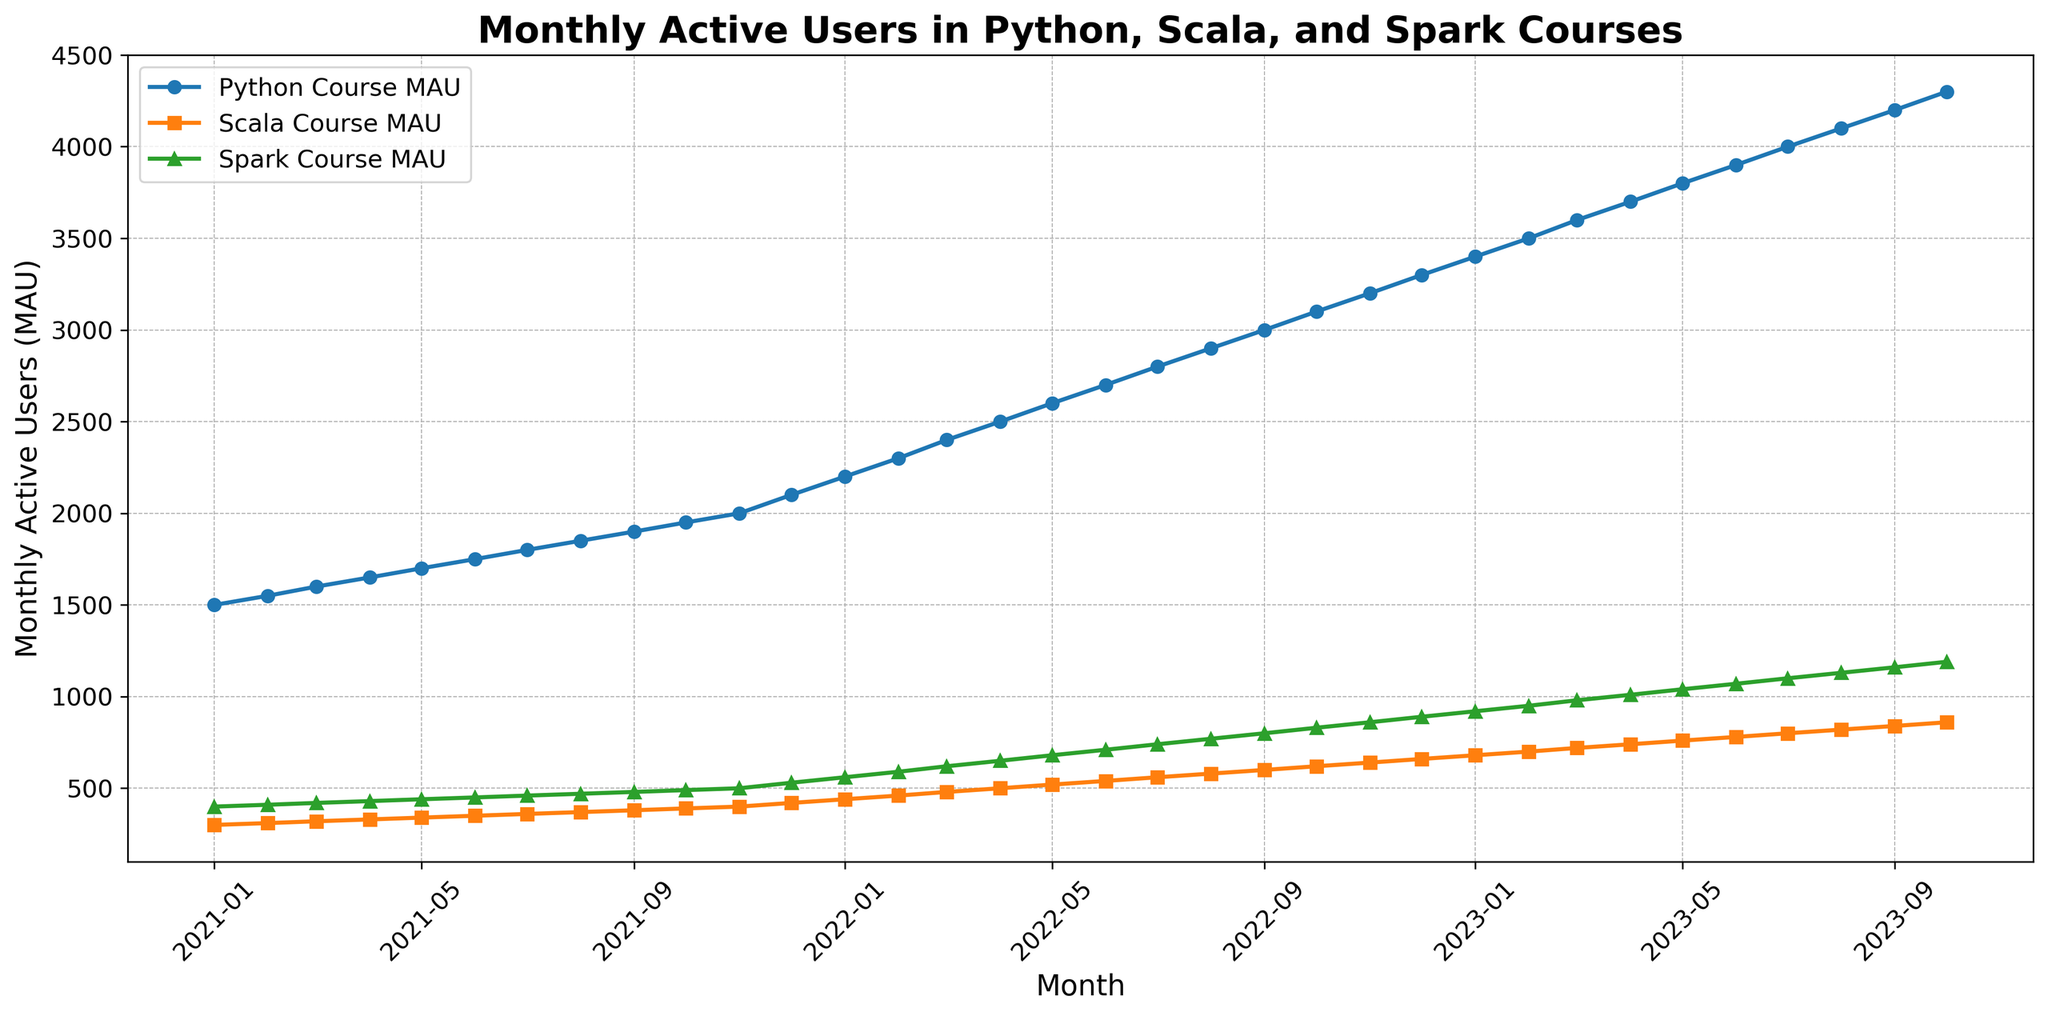What's the average number of Monthly Active Users for the Python course in 2022? Sum the monthly values for Python Course MAU from January 2022 to December 2022 and divide by 12. (2200 + 2300 + 2400 + 2500 + 2600 + 2700 + 2800 + 2900 + 3000 + 3100 + 3200 + 3300) = 35200, and 35200 / 12 = 2933.33. Thus, the average number of Monthly Active Users for the Python course in 2022 is 2933.33
Answer: 2933.33 Which course had the highest Monthly Active Users in October 2023? Compare the values of Python_Course_MAU, Scala_Course_MAU, and Spark_Course_MAU for October 2023. Python: 4300, Scala: 860, Spark: 1190. Python has the highest value.
Answer: Python Course What is the difference between the Monthly Active Users for the Scala course and the Spark course in January 2023? Subtract the number of Monthly Active Users for the Scala course from the number of Monthly Active Users for the Spark course in January 2023. 920 (Spark) - 680 (Scala) = 240.
Answer: 240 How many more Monthly Active Users did the Python course have compared to the Scala course in January 2021? Subtract the number of Monthly Active Users for the Scala course from the number of Monthly Active Users for the Python course in January 2021. 1500 (Python) - 300 (Scala) = 1200.
Answer: 1200 What trend can be observed for the Monthly Active Users in the Spark course over the given period? By examining the plotted line for the Spark course, we observe a consistent upward trend starting from 400 in January 2021 to 1190 in October 2023. The trend indicates continuous growth in user engagement with the Spark course.
Answer: Upward trend Calculate the total number of Monthly Active Users for the Scala course in the first half of 2022 (Jan to Jun). Sum the Monthly Active Users for the Scala course from Jan 2022 to Jun 2022. (440 + 460 + 480 + 500 + 520 + 540) = 2940.
Answer: 2940 What is the average growth in Monthly Active Users for the Python course per month from January 2021 to October 2023? Calculate the average monthly increase by taking the difference between the first and last value in the period and dividing by the number of months. (4300 (October 2023) - 1500 (January 2021)) / 34 months = 82.35 approx.
Answer: 82.35 Which course had the smallest increase in Monthly Active Users from January 2021 to January 2022? Calculate the difference in Monthly Active Users for each course during the period. Python's increase: 2200 - 1500 = 700. Scala's increase: 440 - 300 = 140. Spark's increase: 560 - 400 = 160. Scala had the smallest increase.
Answer: Scala Course What visual characteristics distinguish the Python, Scala, and Spark course lines? The Python course line is marked by circles and colored blue. The Scala course line has square markers and is colored orange. The Spark course line is marked by triangles and colored green.
Answer: Different markers and colors Which month had the highest combined Monthly Active Users for all three courses? Calculate the sum of Monthly Active Users for each month and determine the highest. October 2023 has the highest combined sum (4300 + 860 + 1190 = 6350).
Answer: October 2023 